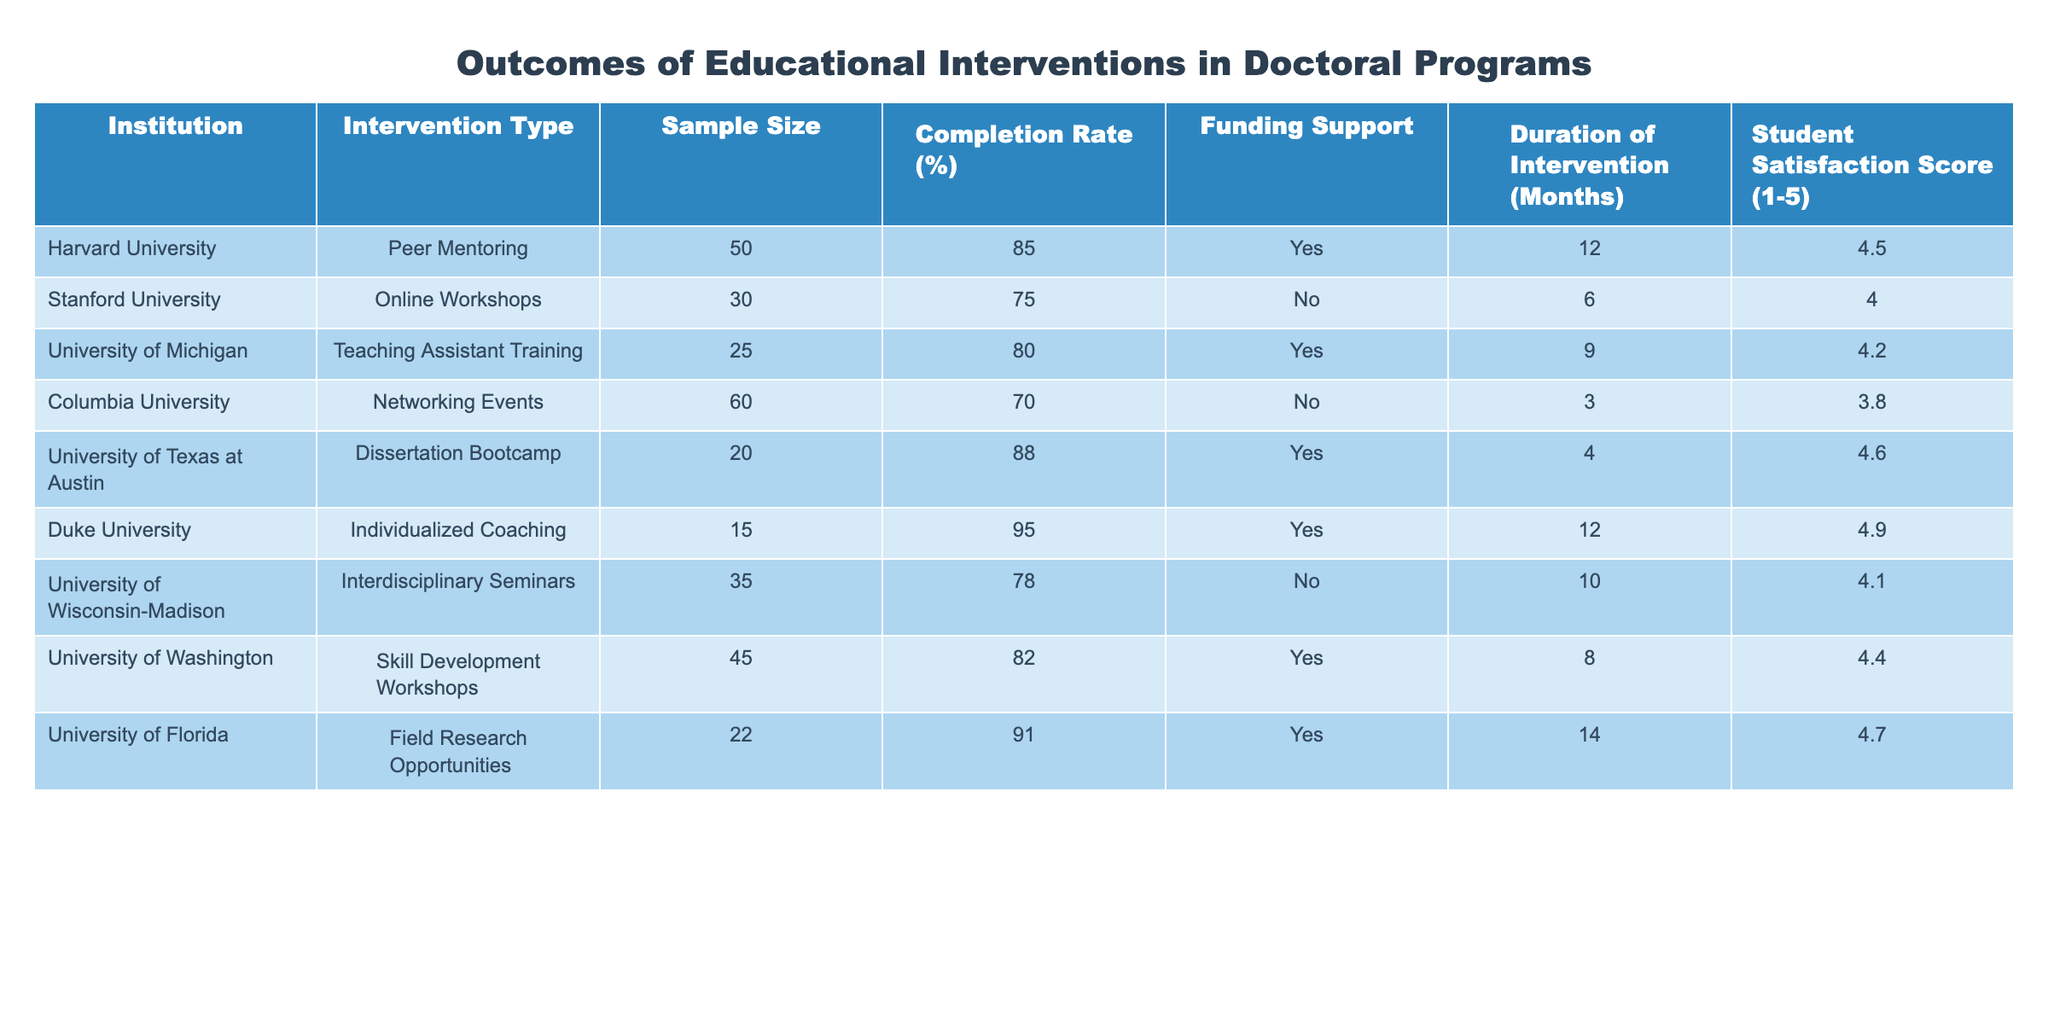What is the completion rate for the Dissertation Bootcamp at the University of Texas at Austin? The completion rate for the Dissertation Bootcamp is directly stated in the table under the corresponding row for the University of Texas at Austin, which shows a completion rate of 88%.
Answer: 88% Which institution offered the highest student satisfaction score? By comparing the student satisfaction scores listed in the table, Duke University has the highest score of 4.9, as indicated in its row.
Answer: 4.9 How many institutions provided funding support for their interventions? The table lists funding support and shows that 6 out of the 10 institutions (Harvard, University of Michigan, University of Texas at Austin, Duke University, University of Florida, and University of Washington) received funding support, which can be counted from the 'Funding Support' column.
Answer: 6 What is the average completion rate across all interventions listed in the table? To find the average completion rate, sum all the completion rates: (85 + 75 + 80 + 70 + 88 + 95 + 78 + 82 + 91) = 64.5. There are 9 interventions, thus the average is 764/9 ≈ 85.33%.
Answer: 85.33% Is there a correlation between the duration of the intervention and student satisfaction scores? Examining the data, both the duration of the intervention and student satisfaction scores show some degree of variability; thus, a deeper statistical analysis would be necessary to confirm correlation. However, simply observing the table does not provide definitive evidence of correlation, so we conclude that no clear correlation can be identified just by visual inspection.
Answer: No 